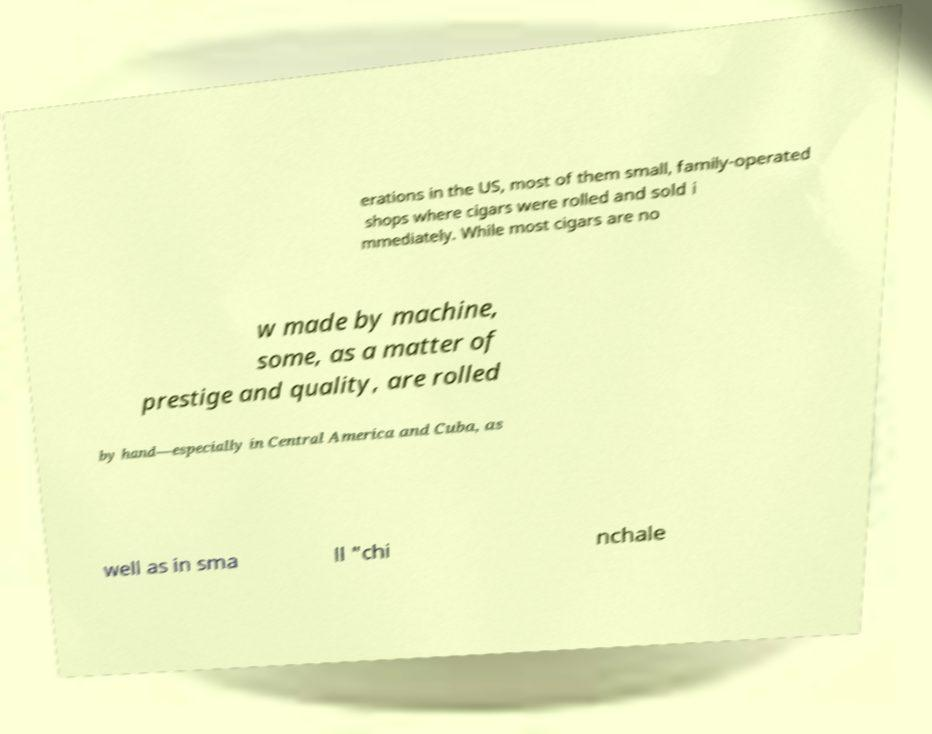Can you accurately transcribe the text from the provided image for me? erations in the US, most of them small, family-operated shops where cigars were rolled and sold i mmediately. While most cigars are no w made by machine, some, as a matter of prestige and quality, are rolled by hand—especially in Central America and Cuba, as well as in sma ll "chi nchale 